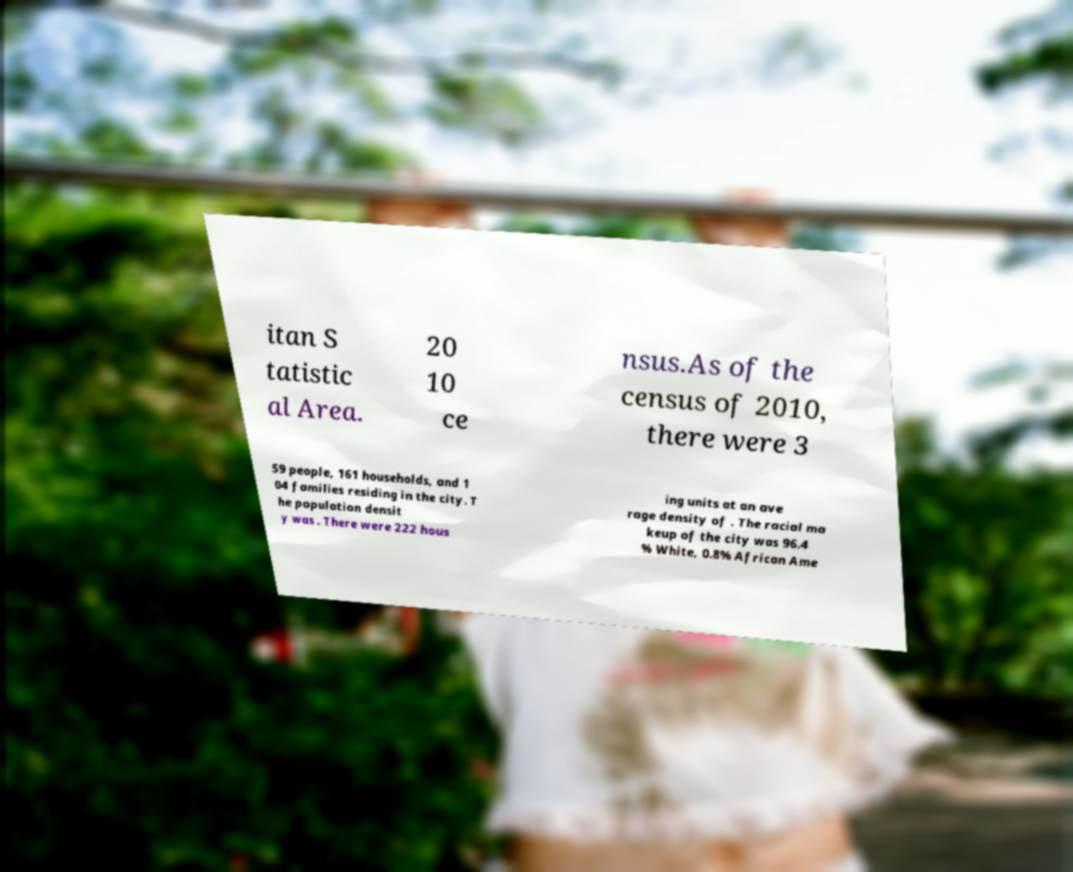What messages or text are displayed in this image? I need them in a readable, typed format. itan S tatistic al Area. 20 10 ce nsus.As of the census of 2010, there were 3 59 people, 161 households, and 1 04 families residing in the city. T he population densit y was . There were 222 hous ing units at an ave rage density of . The racial ma keup of the city was 96.4 % White, 0.8% African Ame 